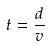Convert formula to latex. <formula><loc_0><loc_0><loc_500><loc_500>t = \frac { d } { v }</formula> 